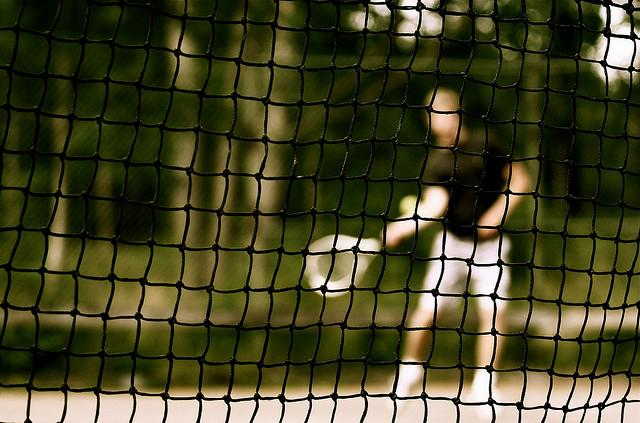This person is playing a similar sport to whom?

Choices:
A) lennox lewis
B) serena williams
C) jordan spieth
D) bucky dent serena williams 